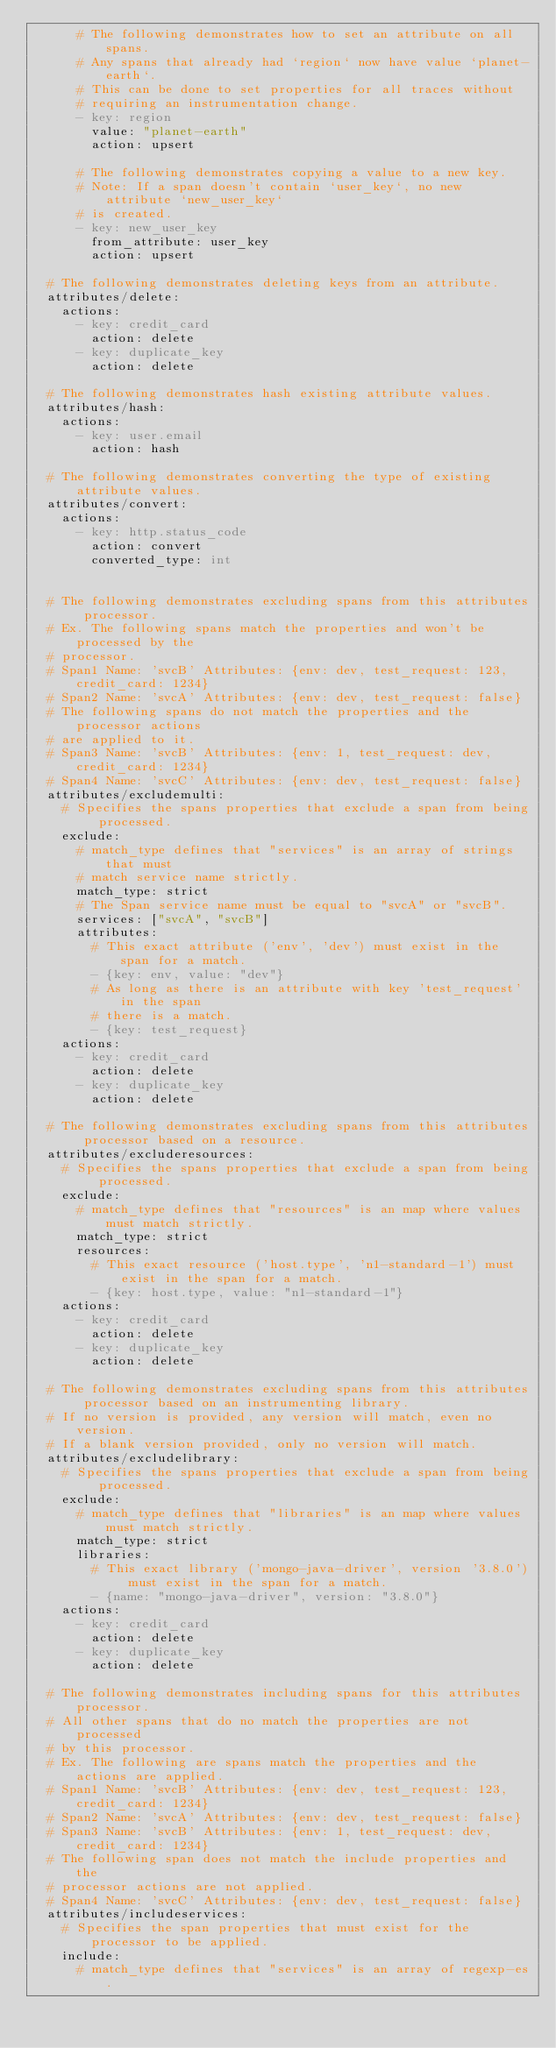<code> <loc_0><loc_0><loc_500><loc_500><_YAML_>      # The following demonstrates how to set an attribute on all spans.
      # Any spans that already had `region` now have value `planet-earth`.
      # This can be done to set properties for all traces without
      # requiring an instrumentation change.
      - key: region
        value: "planet-earth"
        action: upsert

      # The following demonstrates copying a value to a new key.
      # Note: If a span doesn't contain `user_key`, no new attribute `new_user_key`
      # is created.
      - key: new_user_key
        from_attribute: user_key
        action: upsert

  # The following demonstrates deleting keys from an attribute.
  attributes/delete:
    actions:
      - key: credit_card
        action: delete
      - key: duplicate_key
        action: delete

  # The following demonstrates hash existing attribute values.
  attributes/hash:
    actions:
      - key: user.email
        action: hash

  # The following demonstrates converting the type of existing attribute values.
  attributes/convert:
    actions:
      - key: http.status_code
        action: convert
        converted_type: int


  # The following demonstrates excluding spans from this attributes processor.
  # Ex. The following spans match the properties and won't be processed by the
  # processor.
  # Span1 Name: 'svcB' Attributes: {env: dev, test_request: 123, credit_card: 1234}
  # Span2 Name: 'svcA' Attributes: {env: dev, test_request: false}
  # The following spans do not match the properties and the processor actions
  # are applied to it.
  # Span3 Name: 'svcB' Attributes: {env: 1, test_request: dev, credit_card: 1234}
  # Span4 Name: 'svcC' Attributes: {env: dev, test_request: false}
  attributes/excludemulti:
    # Specifies the spans properties that exclude a span from being processed.
    exclude:
      # match_type defines that "services" is an array of strings that must
      # match service name strictly.
      match_type: strict
      # The Span service name must be equal to "svcA" or "svcB".
      services: ["svcA", "svcB"]
      attributes:
        # This exact attribute ('env', 'dev') must exist in the span for a match.
        - {key: env, value: "dev"}
        # As long as there is an attribute with key 'test_request' in the span
        # there is a match.
        - {key: test_request}
    actions:
      - key: credit_card
        action: delete
      - key: duplicate_key
        action: delete

  # The following demonstrates excluding spans from this attributes processor based on a resource.
  attributes/excluderesources:
    # Specifies the spans properties that exclude a span from being processed.
    exclude:
      # match_type defines that "resources" is an map where values must match strictly.
      match_type: strict
      resources:
        # This exact resource ('host.type', 'n1-standard-1') must exist in the span for a match.
        - {key: host.type, value: "n1-standard-1"}
    actions:
      - key: credit_card
        action: delete
      - key: duplicate_key
        action: delete

  # The following demonstrates excluding spans from this attributes processor based on an instrumenting library.
  # If no version is provided, any version will match, even no version.
  # If a blank version provided, only no version will match.
  attributes/excludelibrary:
    # Specifies the spans properties that exclude a span from being processed.
    exclude:
      # match_type defines that "libraries" is an map where values must match strictly.
      match_type: strict
      libraries:
        # This exact library ('mongo-java-driver', version '3.8.0') must exist in the span for a match.
        - {name: "mongo-java-driver", version: "3.8.0"}
    actions:
      - key: credit_card
        action: delete
      - key: duplicate_key
        action: delete

  # The following demonstrates including spans for this attributes processor.
  # All other spans that do no match the properties are not processed
  # by this processor.
  # Ex. The following are spans match the properties and the actions are applied.
  # Span1 Name: 'svcB' Attributes: {env: dev, test_request: 123, credit_card: 1234}
  # Span2 Name: 'svcA' Attributes: {env: dev, test_request: false}
  # Span3 Name: 'svcB' Attributes: {env: 1, test_request: dev, credit_card: 1234}
  # The following span does not match the include properties and the
  # processor actions are not applied.
  # Span4 Name: 'svcC' Attributes: {env: dev, test_request: false}
  attributes/includeservices:
    # Specifies the span properties that must exist for the processor to be applied.
    include:
      # match_type defines that "services" is an array of regexp-es.</code> 